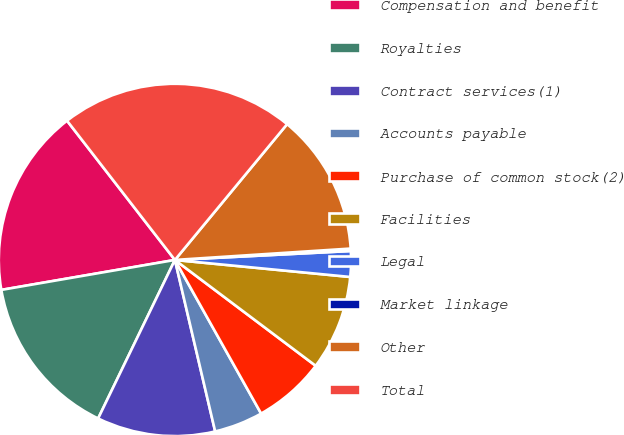Convert chart. <chart><loc_0><loc_0><loc_500><loc_500><pie_chart><fcel>Compensation and benefit<fcel>Royalties<fcel>Contract services(1)<fcel>Accounts payable<fcel>Purchase of common stock(2)<fcel>Facilities<fcel>Legal<fcel>Market linkage<fcel>Other<fcel>Total<nl><fcel>17.23%<fcel>15.1%<fcel>10.85%<fcel>4.47%<fcel>6.6%<fcel>8.72%<fcel>2.35%<fcel>0.22%<fcel>12.98%<fcel>21.48%<nl></chart> 